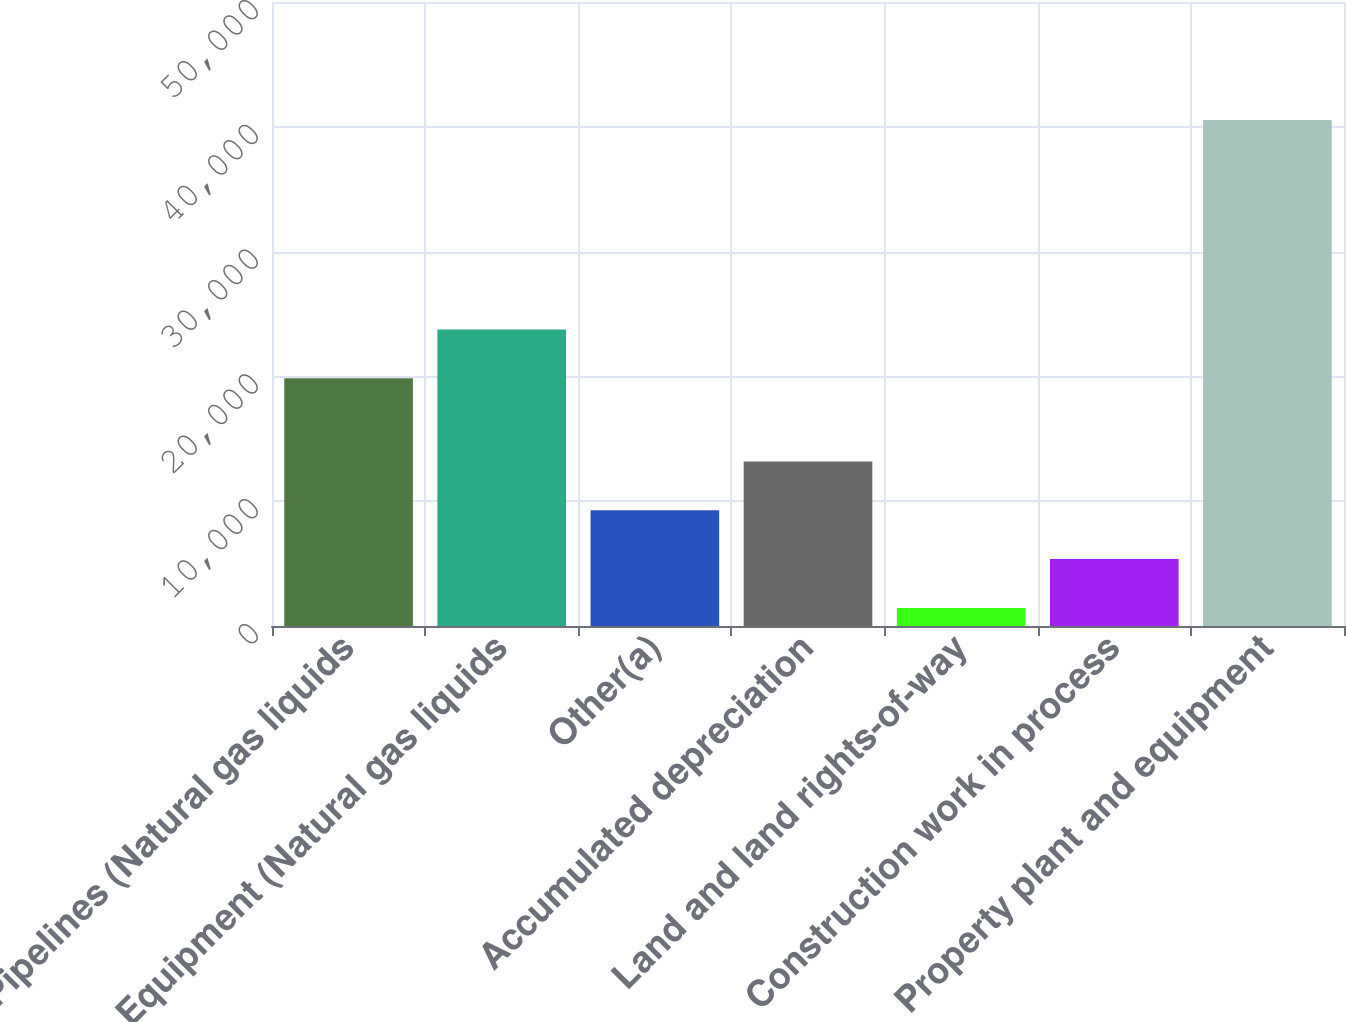<chart> <loc_0><loc_0><loc_500><loc_500><bar_chart><fcel>Pipelines (Natural gas liquids<fcel>Equipment (Natural gas liquids<fcel>Other(a)<fcel>Accumulated depreciation<fcel>Land and land rights-of-way<fcel>Construction work in process<fcel>Property plant and equipment<nl><fcel>19855<fcel>23764.7<fcel>9269.4<fcel>13179.1<fcel>1450<fcel>5359.7<fcel>40547<nl></chart> 